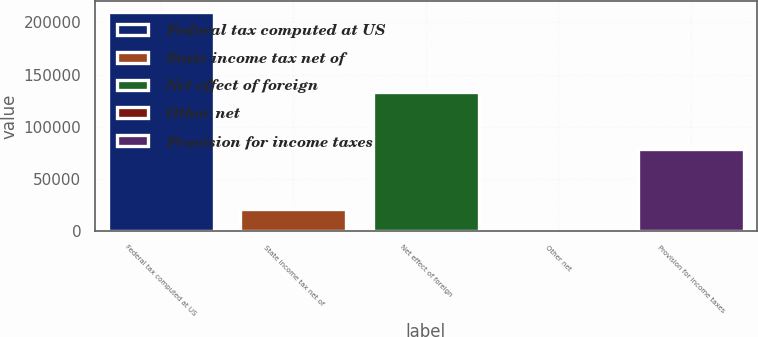Convert chart to OTSL. <chart><loc_0><loc_0><loc_500><loc_500><bar_chart><fcel>Federal tax computed at US<fcel>State income tax net of<fcel>Net effect of foreign<fcel>Other net<fcel>Provision for income taxes<nl><fcel>210040<fcel>21241.6<fcel>133518<fcel>264<fcel>78611<nl></chart> 